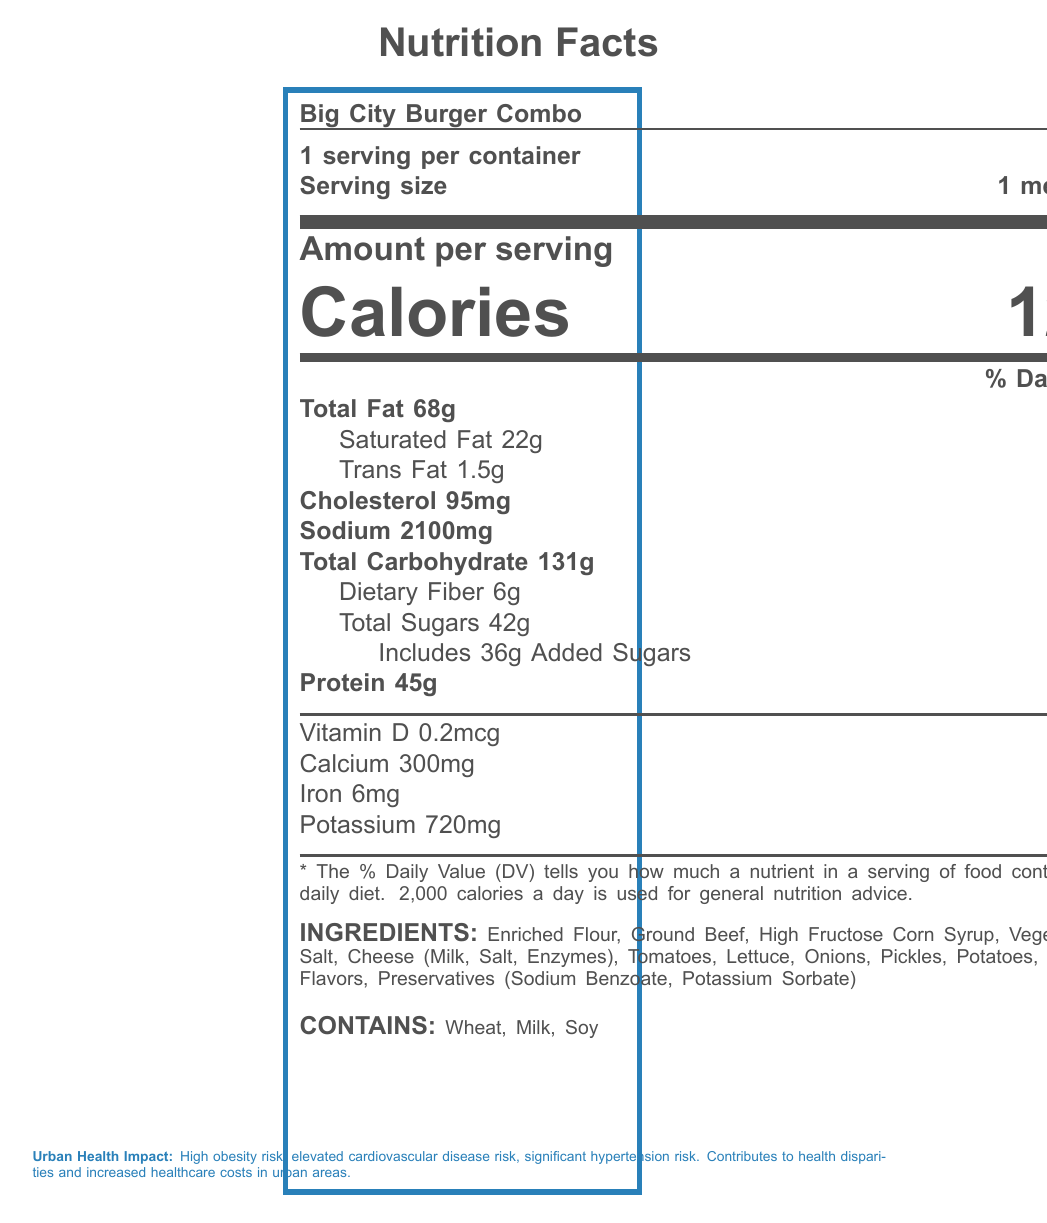what is the serving size for the Big City Burger Combo? The serving size is directly stated on the label as "1 meal (520g)".
Answer: 1 meal (520g) how many calories are in one serving of the Big City Burger Combo? The number of calories per serving is listed as 1280.
Answer: 1280 how much sodium is in one serving of the Big City Burger Combo? The sodium content per serving is mentioned as 2100mg.
Answer: 2100mg what percentage of the daily value for saturated fat does the Big City Burger Combo provide? The document indicates that it contains 22g of saturated fat, which is 110% of the daily value.
Answer: 110% how many grams of protein are there in one serving? The amount of protein per serving is listed as 45g.
Answer: 45g how many grams of trans fat are in the Big City Burger Combo? The label specifies that there are 1.5g of trans fat.
Answer: 1.5g what is the percentage daily value for cholesterol in one serving? The document states that there are 95mg of cholesterol, which is 32% of the daily value.
Answer: 32% what is the percentage daily value for total carbohydrate in one serving? The total carbohydrate content is 131g, which corresponds to 48% of the daily value.
Answer: 48% what is the source of added sugars in the Big City Burger Combo? The ingredients list includes High Fructose Corn Syrup, which contributes to the added sugars.
Answer: High Fructose Corn Syrup what are the top three community health concerns related to the consumption of this fast food meal? The document mentions these as the community health concerns linked to consumption.
Answer: Increased healthcare costs, Reduced productivity, Widening health disparities which of the following nutrients is present in the smallest amount percentage-wise in the Big City Burger Combo? A. Vitamin D B. Calcium C. Iron D. Potassium The document lists Vitamin D as 1% of the daily value, which is the smallest amount compared to Calcium (25%), Iron (35%), and Potassium (15%).
Answer: A. Vitamin D what are the allergens mentioned in the Big City Burger Combo? A. Nuts, Dairy, Gluten B. Wheat, Milk, Soy C. Fish, Eggs, Soy The document clearly states that the allergens are Wheat, Milk, and Soy.
Answer: B. Wheat, Milk, Soy does the Big City Burger Combo have any artificial ingredients? The ingredients list includes Artificial Flavors and Preservatives (Sodium Benzoate, Potassium Sorbate), which are artificial.
Answer: Yes summarize the nutrition and health impact of the Big City Burger Combo based on the document. The document provides detailed nutrition facts about the Big City Burger Combo, emphasizing its high calorie, fat, and sodium content. It also outlines the associated health risks and broader community and environmental impacts.
Answer: The Big City Burger Combo is a high-calorie fast food meal with significant amounts of sodium, fats, and sugars, contributing to high risks of obesity, cardiovascular diseases, and hypertension in urban populations. It contains common allergens including Wheat, Milk, and Soy. The urban health impact includes increased healthcare costs, reduced productivity, and widening health disparities, while also bearing a significant environmental footprint due to high packaging waste, carbon emissions, and water usage. how many calories come from fat in the Big City Burger Combo? The document does not provide information specifically on the calories coming from fat.
Answer: Not enough information 